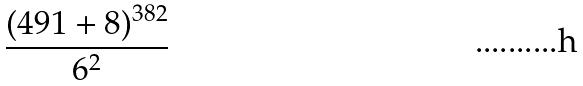Convert formula to latex. <formula><loc_0><loc_0><loc_500><loc_500>\frac { ( 4 9 1 + 8 ) ^ { 3 8 2 } } { 6 ^ { 2 } }</formula> 